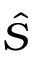Convert formula to latex. <formula><loc_0><loc_0><loc_500><loc_500>\hat { S }</formula> 